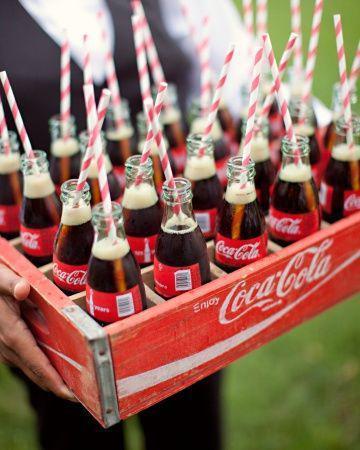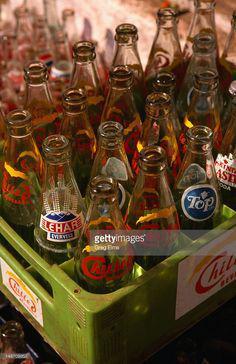The first image is the image on the left, the second image is the image on the right. Assess this claim about the two images: "The left image features filled cola bottles in a red wooden crate with low sides.". Correct or not? Answer yes or no. Yes. The first image is the image on the left, the second image is the image on the right. Considering the images on both sides, is "The bottles in the left image are unopened." valid? Answer yes or no. No. 